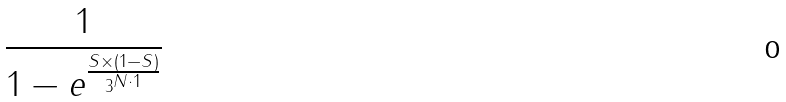<formula> <loc_0><loc_0><loc_500><loc_500>\frac { 1 } { 1 - e ^ { \frac { S \times ( 1 - S ) } { 3 ^ { N \cdot 1 } } } }</formula> 